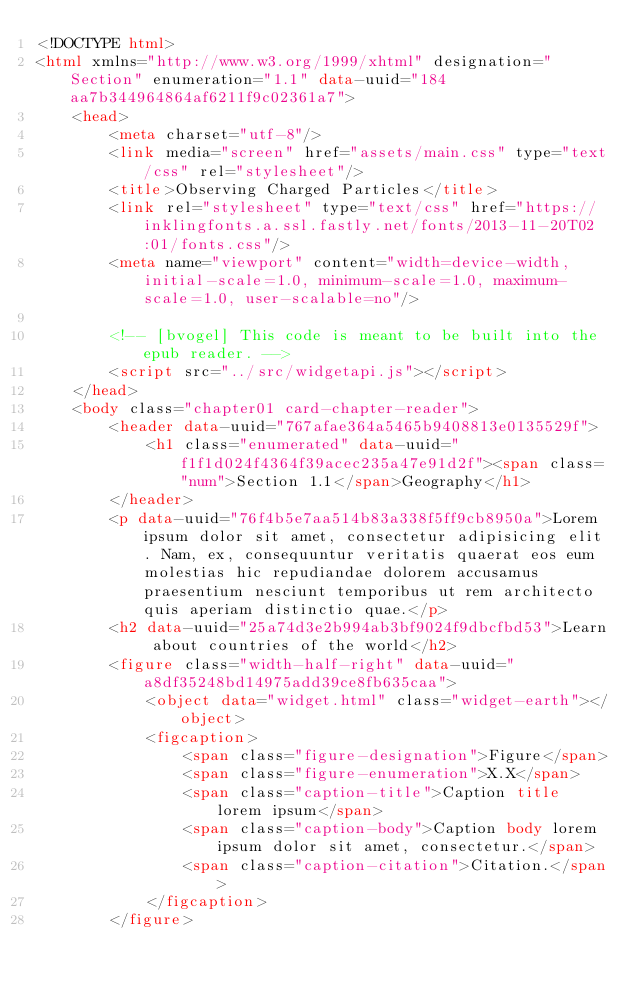Convert code to text. <code><loc_0><loc_0><loc_500><loc_500><_HTML_><!DOCTYPE html>
<html xmlns="http://www.w3.org/1999/xhtml" designation="Section" enumeration="1.1" data-uuid="184aa7b344964864af6211f9c02361a7">
    <head>
        <meta charset="utf-8"/>
        <link media="screen" href="assets/main.css" type="text/css" rel="stylesheet"/>
        <title>Observing Charged Particles</title>
        <link rel="stylesheet" type="text/css" href="https://inklingfonts.a.ssl.fastly.net/fonts/2013-11-20T02:01/fonts.css"/>
        <meta name="viewport" content="width=device-width, initial-scale=1.0, minimum-scale=1.0, maximum-scale=1.0, user-scalable=no"/>

        <!-- [bvogel] This code is meant to be built into the epub reader. -->
        <script src="../src/widgetapi.js"></script>
    </head>
    <body class="chapter01 card-chapter-reader">
        <header data-uuid="767afae364a5465b9408813e0135529f">
            <h1 class="enumerated" data-uuid="f1f1d024f4364f39acec235a47e91d2f"><span class="num">Section 1.1</span>Geography</h1>
        </header>
        <p data-uuid="76f4b5e7aa514b83a338f5ff9cb8950a">Lorem ipsum dolor sit amet, consectetur adipisicing elit. Nam, ex, consequuntur veritatis quaerat eos eum molestias hic repudiandae dolorem accusamus praesentium nesciunt temporibus ut rem architecto quis aperiam distinctio quae.</p>
        <h2 data-uuid="25a74d3e2b994ab3bf9024f9dbcfbd53">Learn about countries of the world</h2>
        <figure class="width-half-right" data-uuid="a8df35248bd14975add39ce8fb635caa">
            <object data="widget.html" class="widget-earth"></object>
            <figcaption>
                <span class="figure-designation">Figure</span>
                <span class="figure-enumeration">X.X</span>
                <span class="caption-title">Caption title lorem ipsum</span>
                <span class="caption-body">Caption body lorem ipsum dolor sit amet, consectetur.</span>
                <span class="caption-citation">Citation.</span>
            </figcaption>
        </figure></code> 